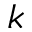<formula> <loc_0><loc_0><loc_500><loc_500>k</formula> 